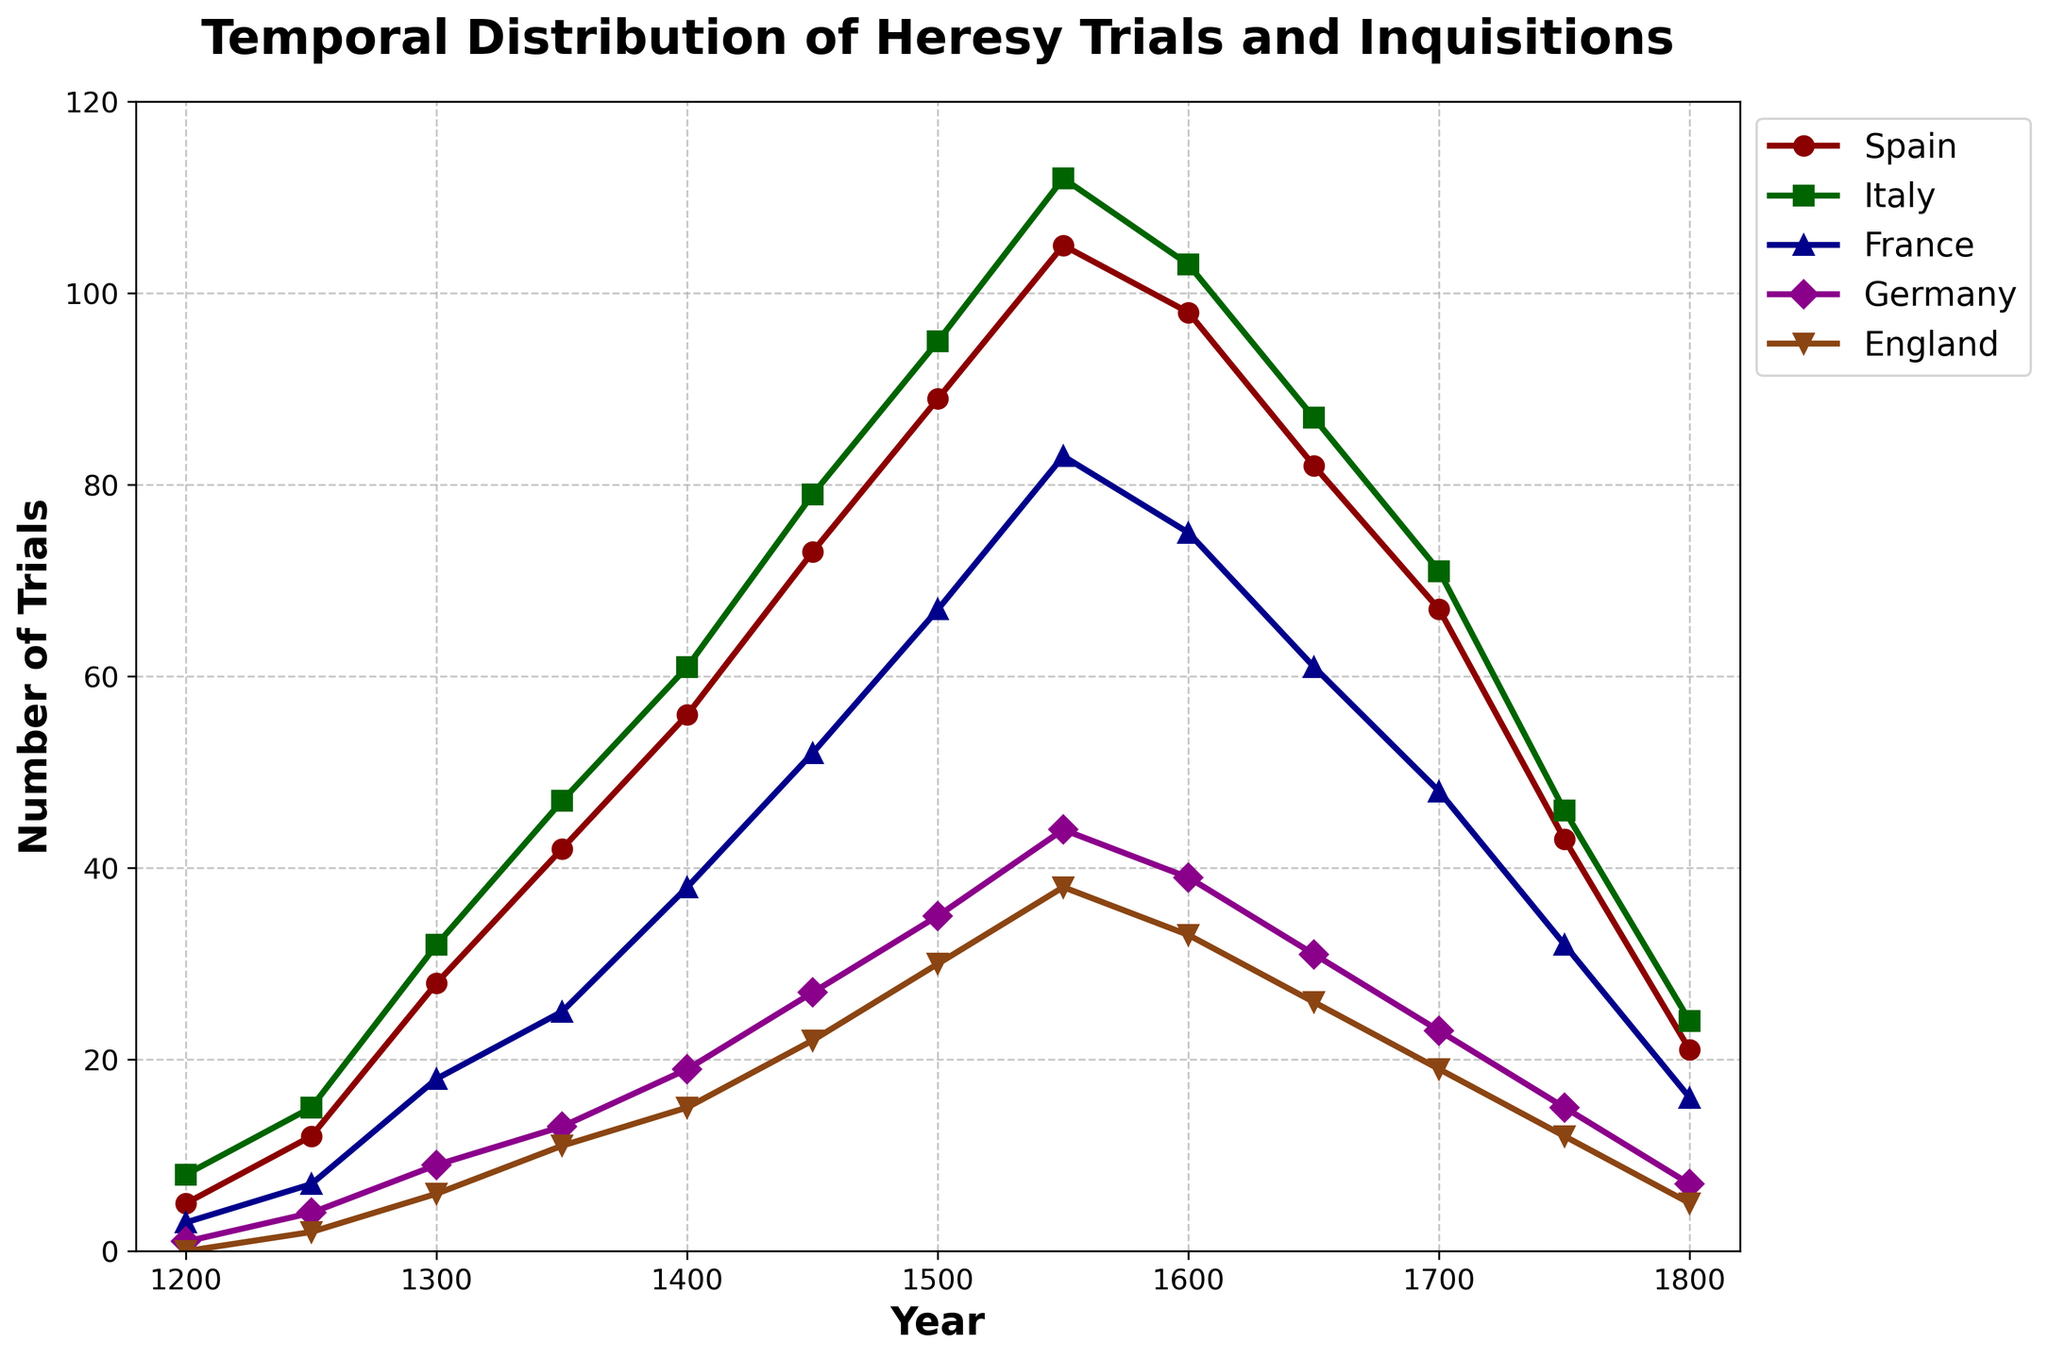What was the total number of heresy trials in Italy and France in 1300? Look at the 'Italy' and 'France' data points for the year 1300. Italy has 32 trials and France has 18 trials. Adding them together: 32 + 18 = 50
Answer: 50 During which year did Spain have the highest number of heresy trials? Observe the 'Spain' data points across all years. The highest value is 105, which occurs in the year 1550
Answer: 1550 Compare the number of heresy trials in Germany between 1450 and 1650. Which year had more trials and by how much? Look at the 'Germany' data points for 1450 and 1650. In 1450, Germany had 27 trials, and in 1650, it had 31 trials. The difference is 31 - 27 = 4
Answer: 1650, by 4 Which region experienced the biggest drop in the number of heresy trials between 1650 and 1750? Examine the difference in the number of trials between 1650 and 1750 for each region: 
Spain: 82 - 43 = 39
Italy: 87 - 46 = 41
France: 61 - 32 = 29
Germany: 31 - 15 = 16
England: 26 - 12 = 14
The biggest drop is for Italy with a decrease of 41 trials
Answer: Italy How did the number of heresy trials in England evolve from 1200 to 1800? Look at the 'England' data points from 1200 to 1800: 0, 2, 6, 11, 15, 22, 30, 38, 33, 26, 19, 12, 5. The trend generally shows a rise to a peak in 1550, followed by a decline
Answer: Increased to a peak in 1550, then declined What is the average number of heresy trials in France across all the recorded years? Sum the 'France' data points across all years and divide by the total number of years: 
3 + 7 + 18 + 25 + 38 + 52 + 67 + 83 + 75 + 61 + 48 + 32 + 16 = 527
The number of years is 13, so the average is 527 / 13 = 40.54
Answer: 40.54 Which two regions had the closest number of heresy trials in 1700 and how much was the difference? Look at the data points for all regions in 1700: 
Spain: 67, Italy: 71, France: 48, Germany: 23, England: 19
The smallest difference is between England and Germany: 23 - 19 = 4
Answer: Germany and England, 4 Identify the period (in years) during which the number of heresy trials in Italy was consistently increasing. Look at the 'Italy' data points: 8, 15, 32, 47, 61, 79, 95, 112. The number of trials is increasing from 1200 (5) to 1550 (112). 
This period spans from 1200 to 1550, giving 1550 - 1200 = 350 years
Answer: 1200 to 1550, 350 years 